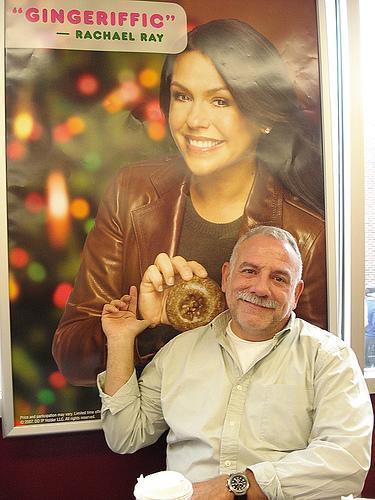How many elephants are lying down?
Give a very brief answer. 0. 